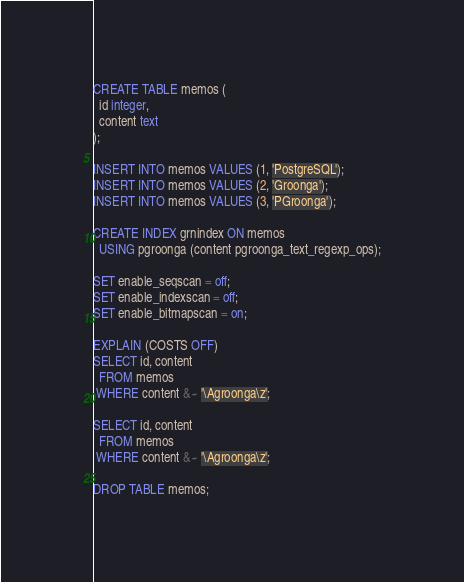<code> <loc_0><loc_0><loc_500><loc_500><_SQL_>CREATE TABLE memos (
  id integer,
  content text
);

INSERT INTO memos VALUES (1, 'PostgreSQL');
INSERT INTO memos VALUES (2, 'Groonga');
INSERT INTO memos VALUES (3, 'PGroonga');

CREATE INDEX grnindex ON memos
  USING pgroonga (content pgroonga_text_regexp_ops);

SET enable_seqscan = off;
SET enable_indexscan = off;
SET enable_bitmapscan = on;

EXPLAIN (COSTS OFF)
SELECT id, content
  FROM memos
 WHERE content &~ '\Agroonga\z';

SELECT id, content
  FROM memos
 WHERE content &~ '\Agroonga\z';

DROP TABLE memos;
</code> 